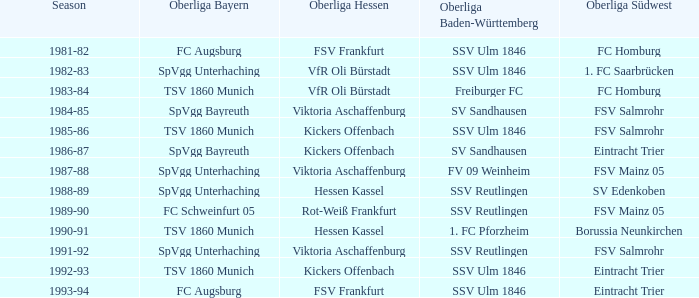Which season has spvgg bayreuth and eintracht trier? 1986-87. 